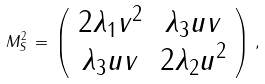<formula> <loc_0><loc_0><loc_500><loc_500>M ^ { 2 } _ { S } \, = \, \left ( \begin{array} { c c } 2 \lambda _ { 1 } v ^ { 2 } & \lambda _ { 3 } u v \\ \lambda _ { 3 } u v & 2 \lambda _ { 2 } u ^ { 2 } \\ \end{array} \right ) \, ,</formula> 